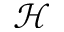<formula> <loc_0><loc_0><loc_500><loc_500>\mathcal { H }</formula> 